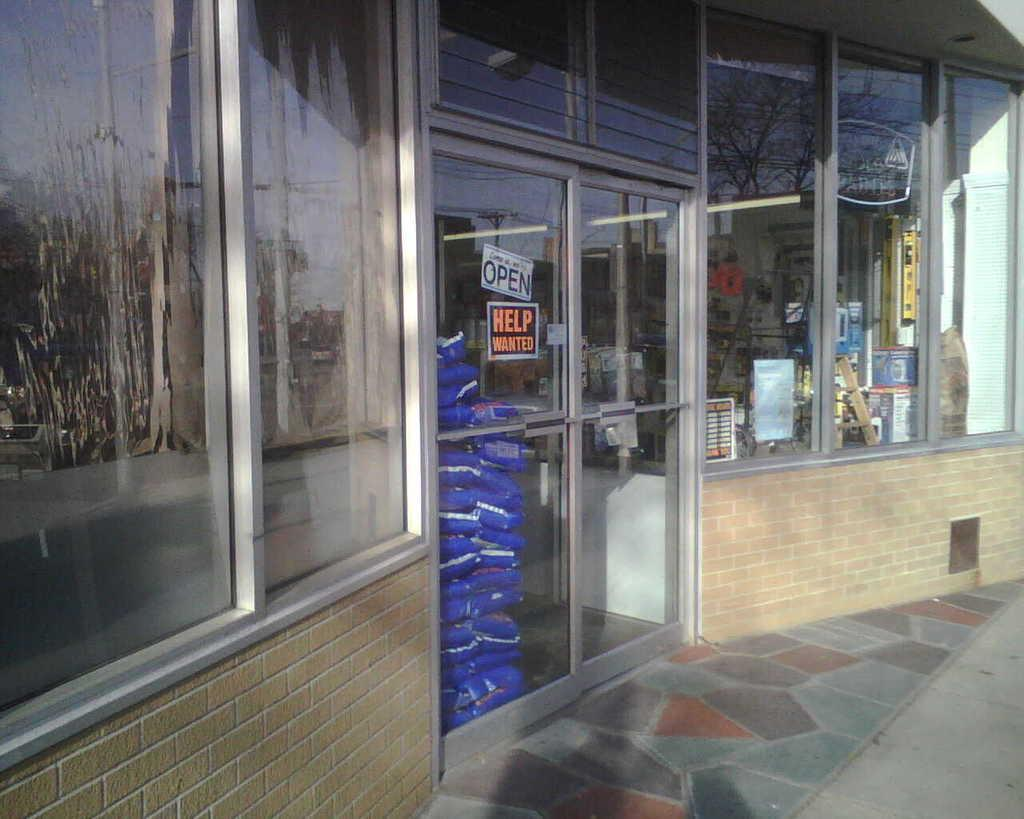<image>
Relay a brief, clear account of the picture shown. On the glass door of a business is a sign that reads "help wanted." 